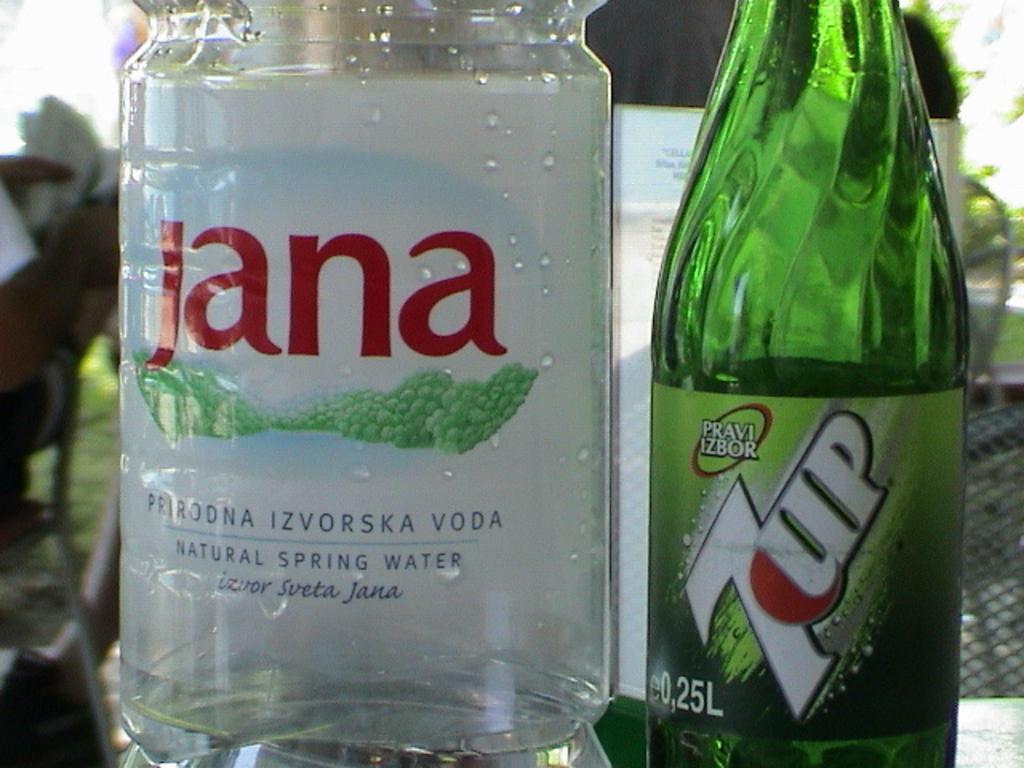How would you summarize this image in a sentence or two? We can see different color bottles on the table and we can see stickers on these bottle.. On the background we can see persons,chair. 